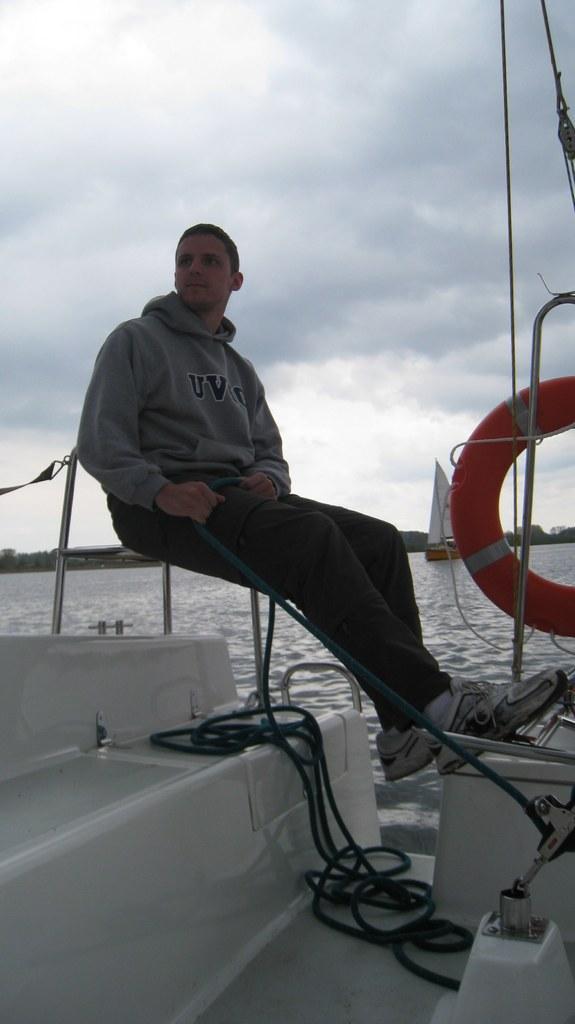Please provide a concise description of this image. In the center of the image we can see person siting on the ship. On the right side of the image we can see air balloon in the ship. In the background we can see water, boat, trees, sky and clouds. 